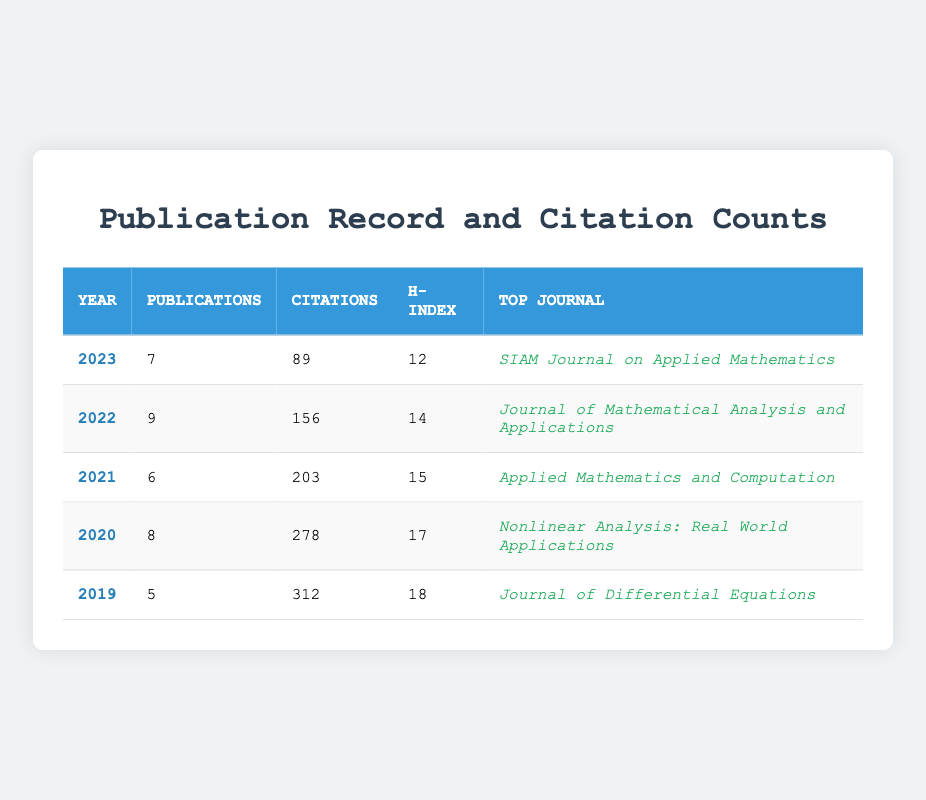What is the top journal for the year 2021? Looking at the table, the "Top Journal" column for 2021 shows "Applied Mathematics and Computation."
Answer: Applied Mathematics and Computation How many publications were made in 2022? The table indicates that there were 9 publications in the year 2022 under the "Publications" column.
Answer: 9 In which year was the highest number of citations received? By examining the "Citations" column, I see that 312 citations were achieved in 2019, which is the highest compared to other years listed.
Answer: 2019 What is the average number of publications over the five years? To find the average, sum the publications: 7 + 9 + 6 + 8 + 5 = 35. Then, divide by the number of years (5): 35 / 5 = 7.
Answer: 7 Did the h-index increase every year? Looking at the h-index values: 18 (2019), 17 (2020), 15 (2021), 14 (2022), 12 (2023), it is clear that the h-index decreased over the years.
Answer: No What is the total number of citations from 2020 to 2022? The citations from 2020 to 2022 are: 278 (2020) + 203 (2021) + 156 (2022) = 637. Thus, the total citations in this range is 637.
Answer: 637 Which year had the highest h-index, and what was the value? Reviewing the h-index column, the highest value is 18 in the year 2019.
Answer: 2019, 18 Was there a year where the number of publications was equal to or greater than the number of citations? By comparing the "Publications" and "Citations" columns, in 2019, there were 5 publications and 312 citations, which means publications never met or exceeded citations in any year.
Answer: No What is the difference in h-index between 2019 and 2023? The h-index in 2019 is 18, and in 2023, it is 12. To find the difference, calculate 18 - 12 = 6.
Answer: 6 